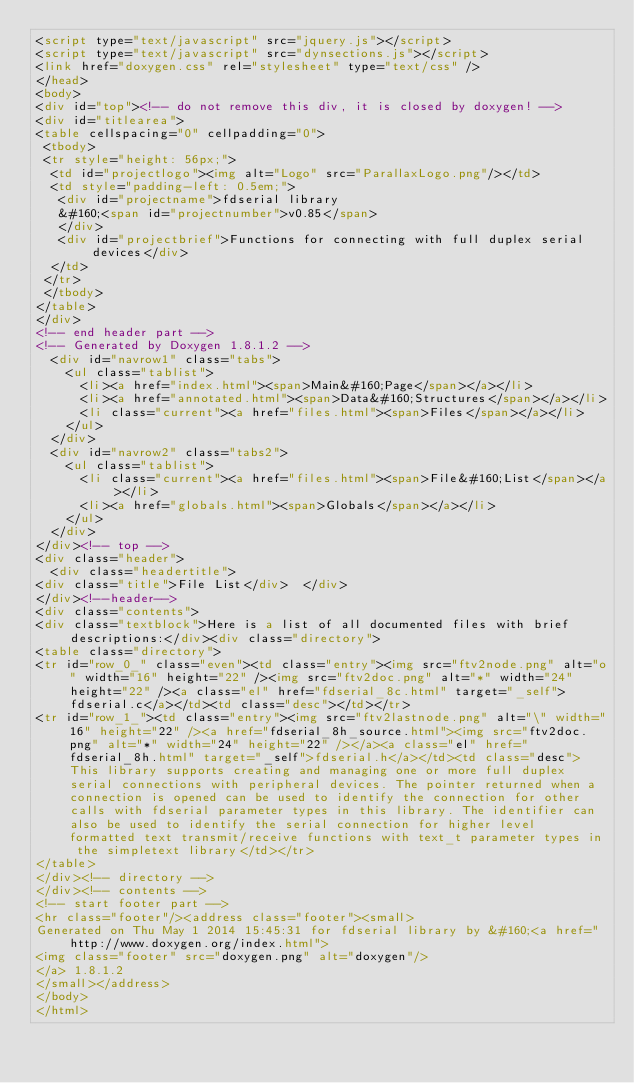<code> <loc_0><loc_0><loc_500><loc_500><_HTML_><script type="text/javascript" src="jquery.js"></script>
<script type="text/javascript" src="dynsections.js"></script>
<link href="doxygen.css" rel="stylesheet" type="text/css" />
</head>
<body>
<div id="top"><!-- do not remove this div, it is closed by doxygen! -->
<div id="titlearea">
<table cellspacing="0" cellpadding="0">
 <tbody>
 <tr style="height: 56px;">
  <td id="projectlogo"><img alt="Logo" src="ParallaxLogo.png"/></td>
  <td style="padding-left: 0.5em;">
   <div id="projectname">fdserial library
   &#160;<span id="projectnumber">v0.85</span>
   </div>
   <div id="projectbrief">Functions for connecting with full duplex serial devices</div>
  </td>
 </tr>
 </tbody>
</table>
</div>
<!-- end header part -->
<!-- Generated by Doxygen 1.8.1.2 -->
  <div id="navrow1" class="tabs">
    <ul class="tablist">
      <li><a href="index.html"><span>Main&#160;Page</span></a></li>
      <li><a href="annotated.html"><span>Data&#160;Structures</span></a></li>
      <li class="current"><a href="files.html"><span>Files</span></a></li>
    </ul>
  </div>
  <div id="navrow2" class="tabs2">
    <ul class="tablist">
      <li class="current"><a href="files.html"><span>File&#160;List</span></a></li>
      <li><a href="globals.html"><span>Globals</span></a></li>
    </ul>
  </div>
</div><!-- top -->
<div class="header">
  <div class="headertitle">
<div class="title">File List</div>  </div>
</div><!--header-->
<div class="contents">
<div class="textblock">Here is a list of all documented files with brief descriptions:</div><div class="directory">
<table class="directory">
<tr id="row_0_" class="even"><td class="entry"><img src="ftv2node.png" alt="o" width="16" height="22" /><img src="ftv2doc.png" alt="*" width="24" height="22" /><a class="el" href="fdserial_8c.html" target="_self">fdserial.c</a></td><td class="desc"></td></tr>
<tr id="row_1_"><td class="entry"><img src="ftv2lastnode.png" alt="\" width="16" height="22" /><a href="fdserial_8h_source.html"><img src="ftv2doc.png" alt="*" width="24" height="22" /></a><a class="el" href="fdserial_8h.html" target="_self">fdserial.h</a></td><td class="desc">This library supports creating and managing one or more full duplex serial connections with peripheral devices. The pointer returned when a connection is opened can be used to identify the connection for other calls with fdserial parameter types in this library. The identifier can also be used to identify the serial connection for higher level formatted text transmit/receive functions with text_t parameter types in the simpletext library</td></tr>
</table>
</div><!-- directory -->
</div><!-- contents -->
<!-- start footer part -->
<hr class="footer"/><address class="footer"><small>
Generated on Thu May 1 2014 15:45:31 for fdserial library by &#160;<a href="http://www.doxygen.org/index.html">
<img class="footer" src="doxygen.png" alt="doxygen"/>
</a> 1.8.1.2
</small></address>
</body>
</html>
</code> 